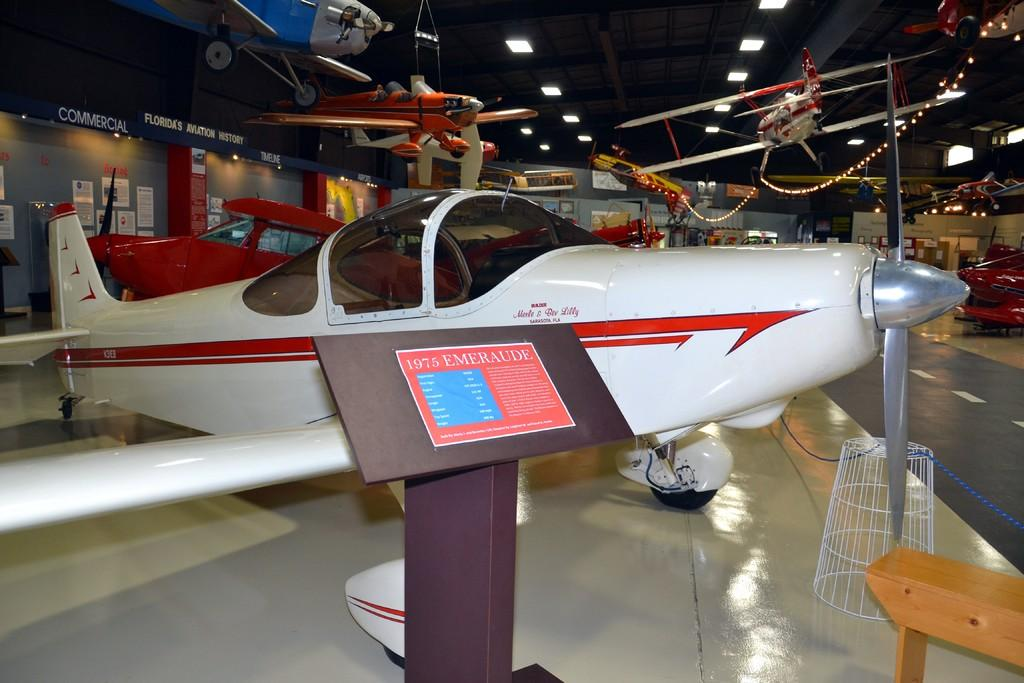What type of vehicles are present in the image? There are helicopters in the image. Where are the helicopters located? The helicopters are in a hall. What can be seen in the background of the image? There is a wall, boards, and lights on a rooftop in the background of the image. What type of location might the image have been taken in? The image may have been taken in a factory. How does the visitor navigate through the quicksand in the image? There is no visitor or quicksand present in the image; it features helicopters in a hall with a background of a wall, boards, and lights on a rooftop. 